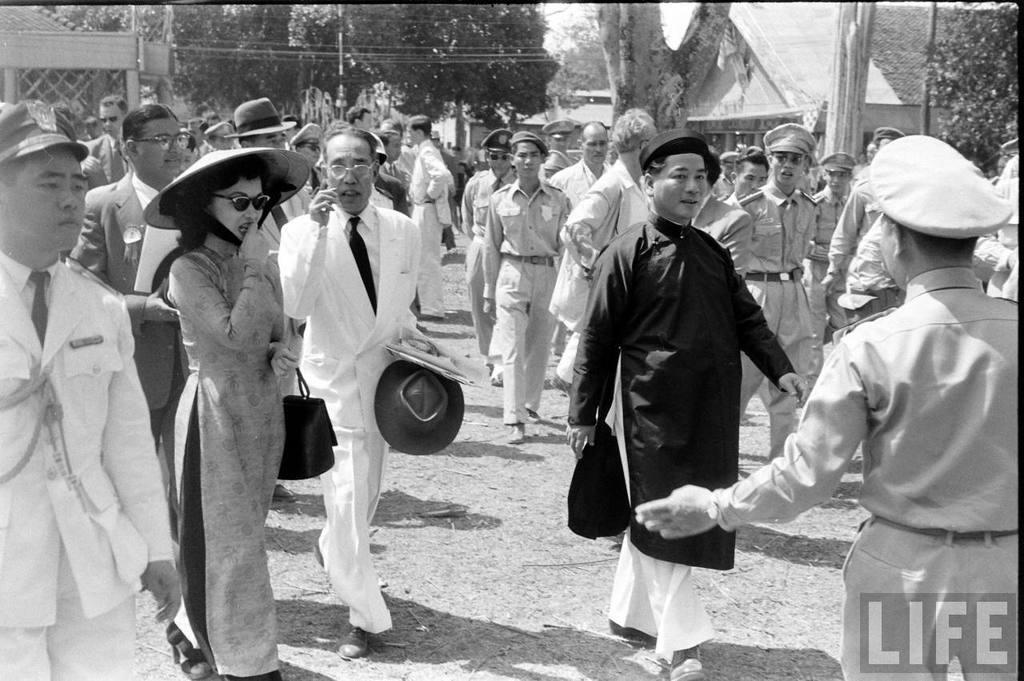What are the people in the image doing? There is a group of people walking in the image. What can be seen in the distance behind the people? There are buildings and trees in the background of the image. What are the vertical structures in the image? There are poles in the image. What is visible at the bottom of the image? The ground is visible at the bottom of the image. Where is the text located in the image? The text is at the bottom right of the image. How many ladybugs can be seen crawling on the edge of the buildings in the image? There are no ladybugs visible in the image, and therefore no such activity can be observed. 